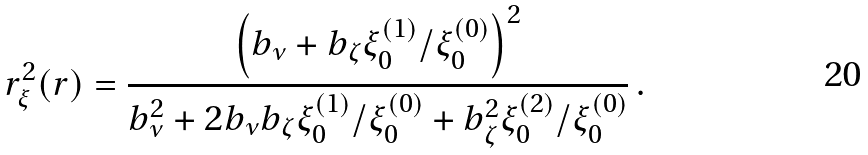Convert formula to latex. <formula><loc_0><loc_0><loc_500><loc_500>r _ { \xi } ^ { 2 } ( r ) = \frac { \left ( b _ { \nu } + b _ { \zeta } \xi _ { 0 } ^ { ( 1 ) } / \xi _ { 0 } ^ { ( 0 ) } \right ) ^ { 2 } } { b _ { \nu } ^ { 2 } + 2 b _ { \nu } b _ { \zeta } \xi _ { 0 } ^ { ( 1 ) } / \xi _ { 0 } ^ { ( 0 ) } + b _ { \zeta } ^ { 2 } \xi _ { 0 } ^ { ( 2 ) } / \xi _ { 0 } ^ { ( 0 ) } } \, .</formula> 